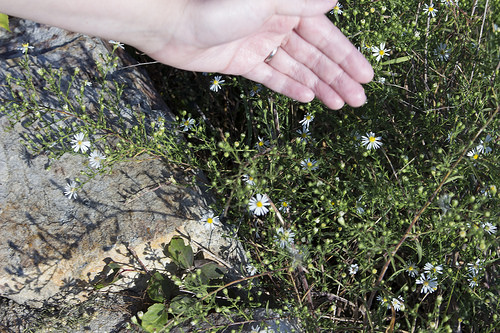<image>
Is the flower in the rock? Yes. The flower is contained within or inside the rock, showing a containment relationship. Where is the flower in relation to the rock? Is it in front of the rock? No. The flower is not in front of the rock. The spatial positioning shows a different relationship between these objects. 